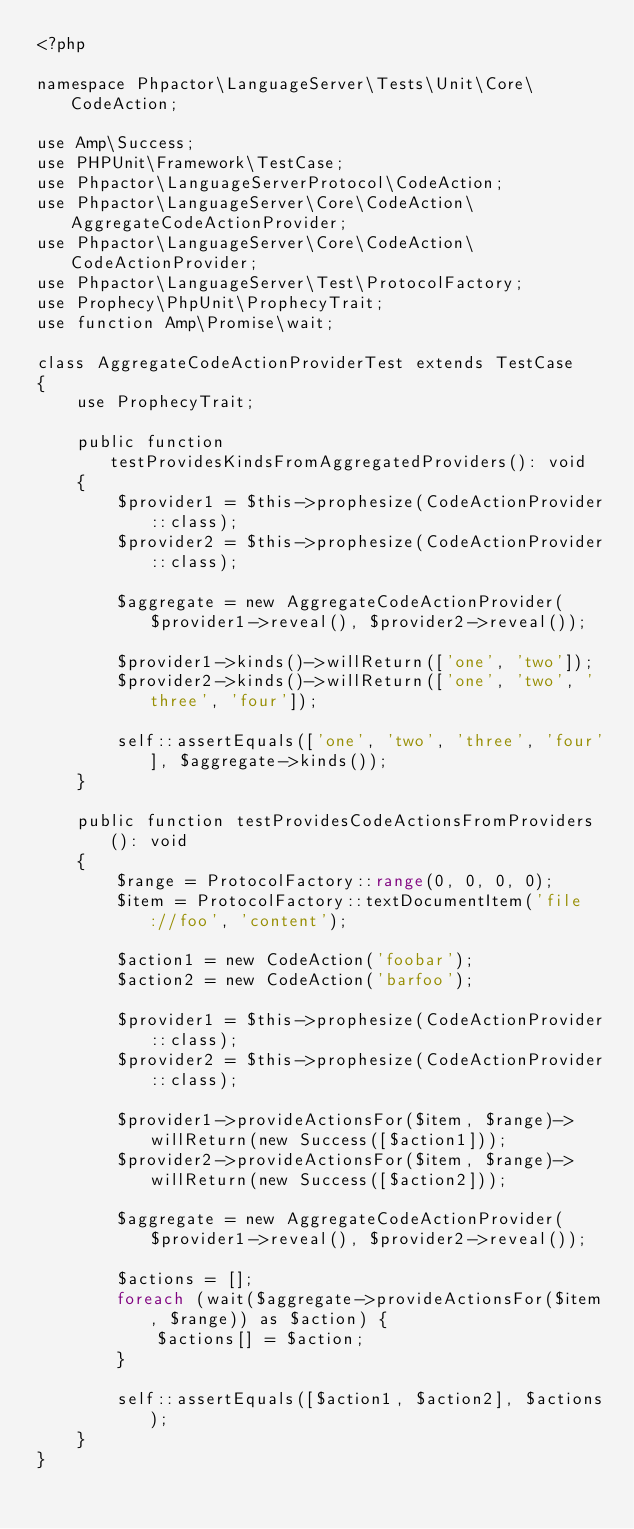Convert code to text. <code><loc_0><loc_0><loc_500><loc_500><_PHP_><?php

namespace Phpactor\LanguageServer\Tests\Unit\Core\CodeAction;

use Amp\Success;
use PHPUnit\Framework\TestCase;
use Phpactor\LanguageServerProtocol\CodeAction;
use Phpactor\LanguageServer\Core\CodeAction\AggregateCodeActionProvider;
use Phpactor\LanguageServer\Core\CodeAction\CodeActionProvider;
use Phpactor\LanguageServer\Test\ProtocolFactory;
use Prophecy\PhpUnit\ProphecyTrait;
use function Amp\Promise\wait;

class AggregateCodeActionProviderTest extends TestCase
{
    use ProphecyTrait;

    public function testProvidesKindsFromAggregatedProviders(): void
    {
        $provider1 = $this->prophesize(CodeActionProvider::class);
        $provider2 = $this->prophesize(CodeActionProvider::class);

        $aggregate = new AggregateCodeActionProvider($provider1->reveal(), $provider2->reveal());

        $provider1->kinds()->willReturn(['one', 'two']);
        $provider2->kinds()->willReturn(['one', 'two', 'three', 'four']);

        self::assertEquals(['one', 'two', 'three', 'four'], $aggregate->kinds());
    }

    public function testProvidesCodeActionsFromProviders(): void
    {
        $range = ProtocolFactory::range(0, 0, 0, 0);
        $item = ProtocolFactory::textDocumentItem('file://foo', 'content');

        $action1 = new CodeAction('foobar');
        $action2 = new CodeAction('barfoo');

        $provider1 = $this->prophesize(CodeActionProvider::class);
        $provider2 = $this->prophesize(CodeActionProvider::class);

        $provider1->provideActionsFor($item, $range)->willReturn(new Success([$action1]));
        $provider2->provideActionsFor($item, $range)->willReturn(new Success([$action2]));

        $aggregate = new AggregateCodeActionProvider($provider1->reveal(), $provider2->reveal());

        $actions = [];
        foreach (wait($aggregate->provideActionsFor($item, $range)) as $action) {
            $actions[] = $action;
        }

        self::assertEquals([$action1, $action2], $actions);
    }
}
</code> 